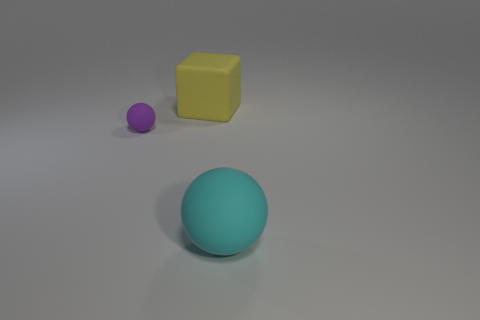Is there a large rubber thing that has the same shape as the small thing?
Ensure brevity in your answer.  Yes. What is the shape of the yellow thing that is the same size as the cyan thing?
Your answer should be compact. Cube. How many big rubber objects are left of the rubber object that is in front of the small purple matte object?
Your answer should be compact. 1. What size is the rubber object that is both behind the large cyan object and in front of the big yellow block?
Make the answer very short. Small. Are there any rubber objects that have the same size as the yellow cube?
Keep it short and to the point. Yes. Is the number of large rubber objects behind the tiny purple ball greater than the number of small purple objects that are to the right of the large yellow cube?
Provide a succinct answer. Yes. Does the yellow object have the same material as the purple ball left of the big rubber sphere?
Give a very brief answer. Yes. There is a sphere right of the big yellow matte thing behind the tiny sphere; what number of tiny purple balls are right of it?
Your answer should be compact. 0. Do the purple rubber object and the big matte object in front of the small purple sphere have the same shape?
Your answer should be very brief. Yes. What is the color of the object that is left of the big cyan ball and to the right of the small purple matte object?
Your answer should be compact. Yellow. 